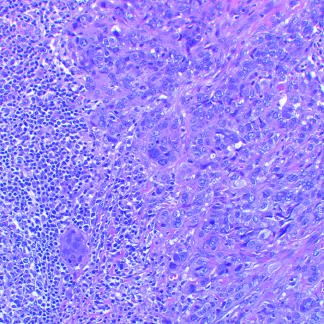what do carcinomas consist of?
Answer the question using a single word or phrase. Tightly adhesive clusters of cells 